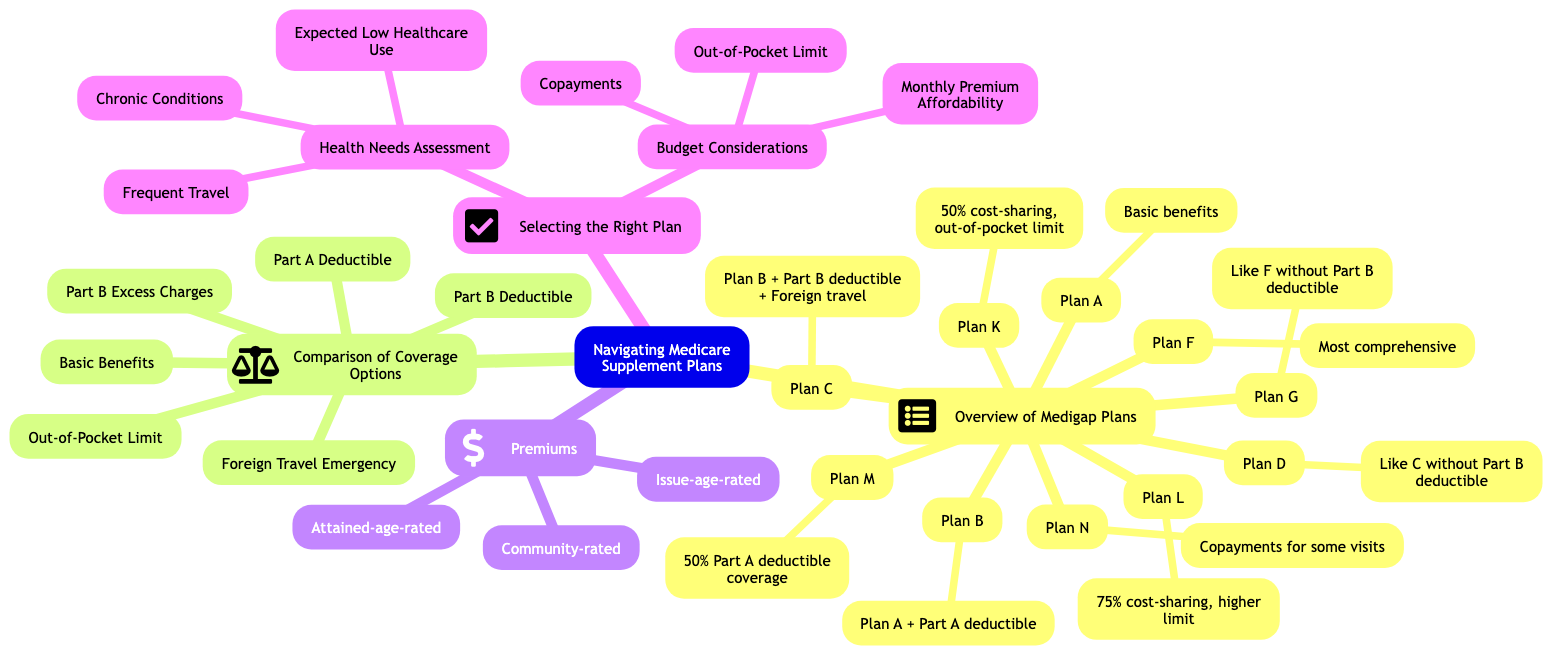What are the basic benefits of Plan A? Plan A offers basic benefits covering hospital coinsurance and costs up to 365 days after Original Medicare benefits are exhausted. This is explicitly stated in the "Overview of Medigap Plans" section under Plan A.
Answer: Basic benefits covering hospital coinsurance and costs up to 365 days after Original Medicare benefits are exhausted Which Medigap plans cover the Part A deductible? The plans that provide coverage for the Part A deductible are listed under the "Part A Deductible" category in the "Comparison of Coverage Options" section. Specifically, they include Plan B, Plan C, Plan D, Plan F, Plan G, and Plan M.
Answer: Plan B, Plan C, Plan D, Plan F, Plan G, Plan M How many plans are listed in the Overview of Medigap Plans? The "Overview of Medigap Plans" section contains 10 different plans (A through N), as each plan is distinctly mentioned and described in the diagram.
Answer: 10 What plan would be suitable for someone expecting low healthcare use? Based on the "Health Needs Assessment" section under "Selecting the Right Plan," the recommendation for someone expecting low healthcare use is to choose plans like Plan N, which offer lower premiums but higher out-of-pocket costs.
Answer: Plan N Which type of premiums increases as you get older? The "Attained-age-rated" premiums are specifically noted for increasing as you get older in the "Premiums" section of the diagram. This is contrasted with other types of premiums that do not change based on age.
Answer: Attained-age-rated What type of cost-sharing does Plan K offer? Plan K is indicated in the Overview of Medigap Plans section to have 50% cost-sharing on services along with providing an out-of-pocket limit.
Answer: 50% cost-sharing Which plans provide coverage for foreign travel emergencies? The "Foreign Travel Emergency" category lists several plans that offer this coverage, specifically Plan C, Plan D, Plan F, Plan G, and Plan N. This is detailed under the "Comparison of Coverage Options."
Answer: Plan C, Plan D, Plan F, Plan G, Plan N What is the difference between community-rated and issue-age-rated premiums? Community-rated premiums are the same for all policyholders regardless of age, while issue-age-rated premiums are based on the age when the policy is purchased, meaning younger individuals pay less. This comparison can be drawn from the description under the "Premiums" section.
Answer: Same for all vs. based on purchase age 